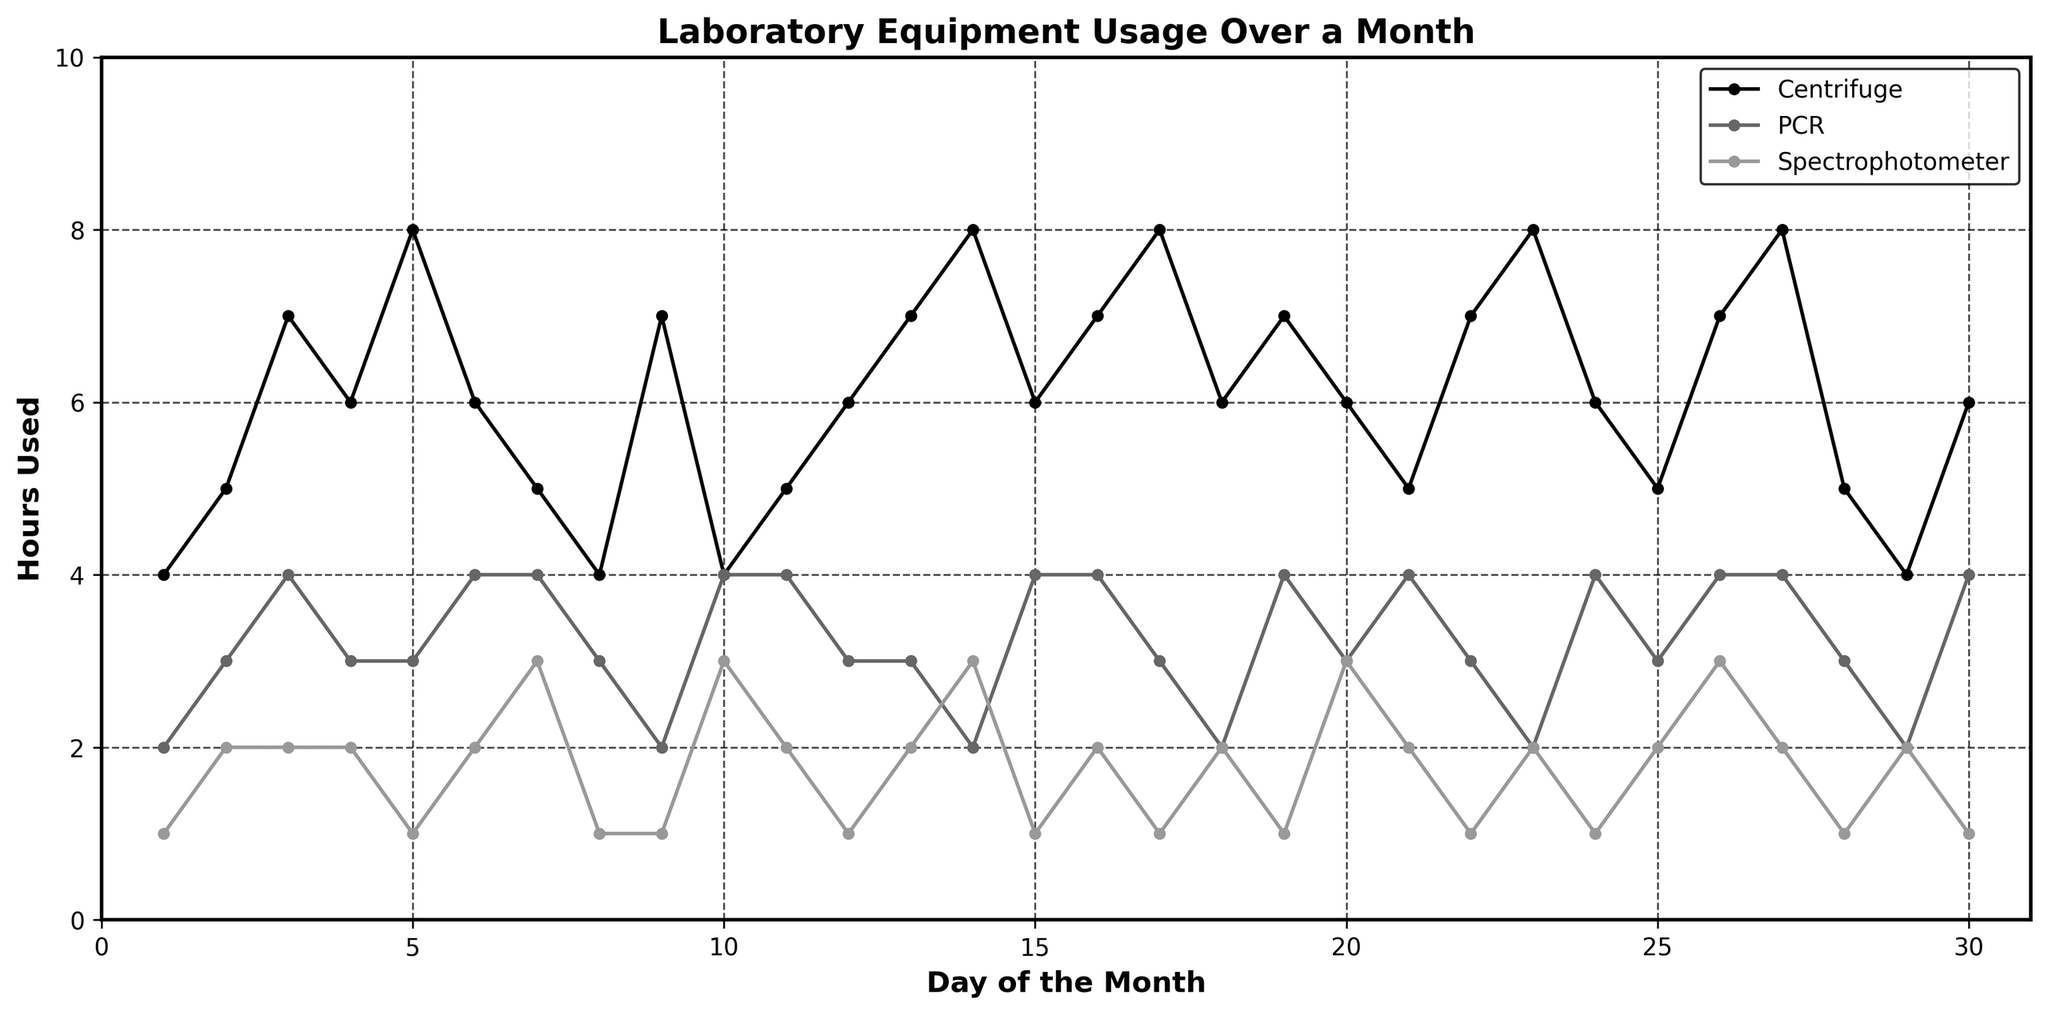What is the title of the figure? The title is displayed at the top of the figure.
Answer: Laboratory Equipment Usage Over a Month Which equipment has the highest usage on day 10? By examining the lines on day 10, the Centrifuge has the highest usage with 4 hours.
Answer: Centrifuge What is the range of hours used for the Spectrophotometer throughout the month? The Spectrophotometer usage ranges from 1 to 3 hours.
Answer: 1 to 3 hours What is the average hours used per day for the PCR machine over the month? Calculate the average by summing up the hours used for the PCR machine over 30 days (88 hours) and then dividing by 30.
Answer: 2.93 hours Which lab equipment has the most consistent usage over the month? Observe the relatively flat or least variable line; the Spectrophotometer's usage ranges narrowly from 1 to 3 hours.
Answer: Spectrophotometer On which day did the Centrifuge reach its peak usage? Identify the day with highest point for the Centrifuge. Day 5, Day 14, Day 17, Day 23, and Day 27 show peaks at 8 hours.
Answer: Day 5, 14, 17, 23, 27 How does the usage pattern of the Centrifuge differ from that of the PCR machine? Compare the variability; the Centrifuge shows more fluctuations and higher peaks, while the PCR machine has a more moderate and steady pattern.
Answer: More fluctuations and higher peaks What is the total usage of the Spectrophotometer over the month? Sum the daily hours used for the Spectrophotometer (1+2+2+2+...+1) which equals 42 hours.
Answer: 42 hours How many days did the PCR machine usage never exceed 3 hours? By observing the graph, the PCR machine usage does not exceed 3 hours on days 1, 2, 9, 13, 14, 18, 22, 23, 25, 28, and 29.
Answer: 11 days On which day do all three pieces of equipment have the same usage? Check the graph for intersections where all three lines meet. On day 9, all three reach either 3 or 4 hours.
Answer: Day 9 